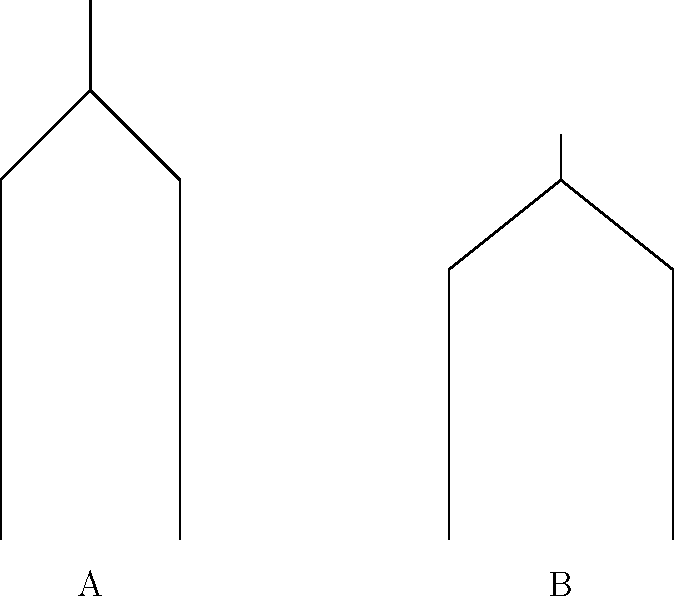As a historical architecture enthusiast from Derbyshire, you're familiar with various cathedral styles. Based on the cross-sectional diagrams above, which architectural style does Cathedral A represent? To identify the architectural style of Cathedral A, let's analyze its key features:

1. Height: Cathedral A is noticeably taller than Cathedral B.
2. Roof shape: Cathedral A has a steeply pitched roof forming a pointed arch at the top.
3. Wall structure: The walls of Cathedral A appear to be thinner and taller compared to Cathedral B.
4. Support system: There's an indication of external support structures (likely flying buttresses) in Cathedral A.

These characteristics are hallmarks of the Gothic architectural style:

1. Gothic cathedrals were known for their impressive height, often much taller than their Romanesque predecessors.
2. The pointed arch is a defining feature of Gothic architecture, allowing for greater height and larger windows.
3. Gothic cathedrals had thinner walls due to the innovative use of ribbed vaults and flying buttresses.
4. Flying buttresses were external supports that allowed for taller, thinner walls and larger windows.

In contrast, Cathedral B shows features typical of Romanesque architecture:
- Lower overall height
- Rounded arch at the top
- Thicker walls for support

Therefore, based on these observations, Cathedral A represents the Gothic architectural style.
Answer: Gothic 